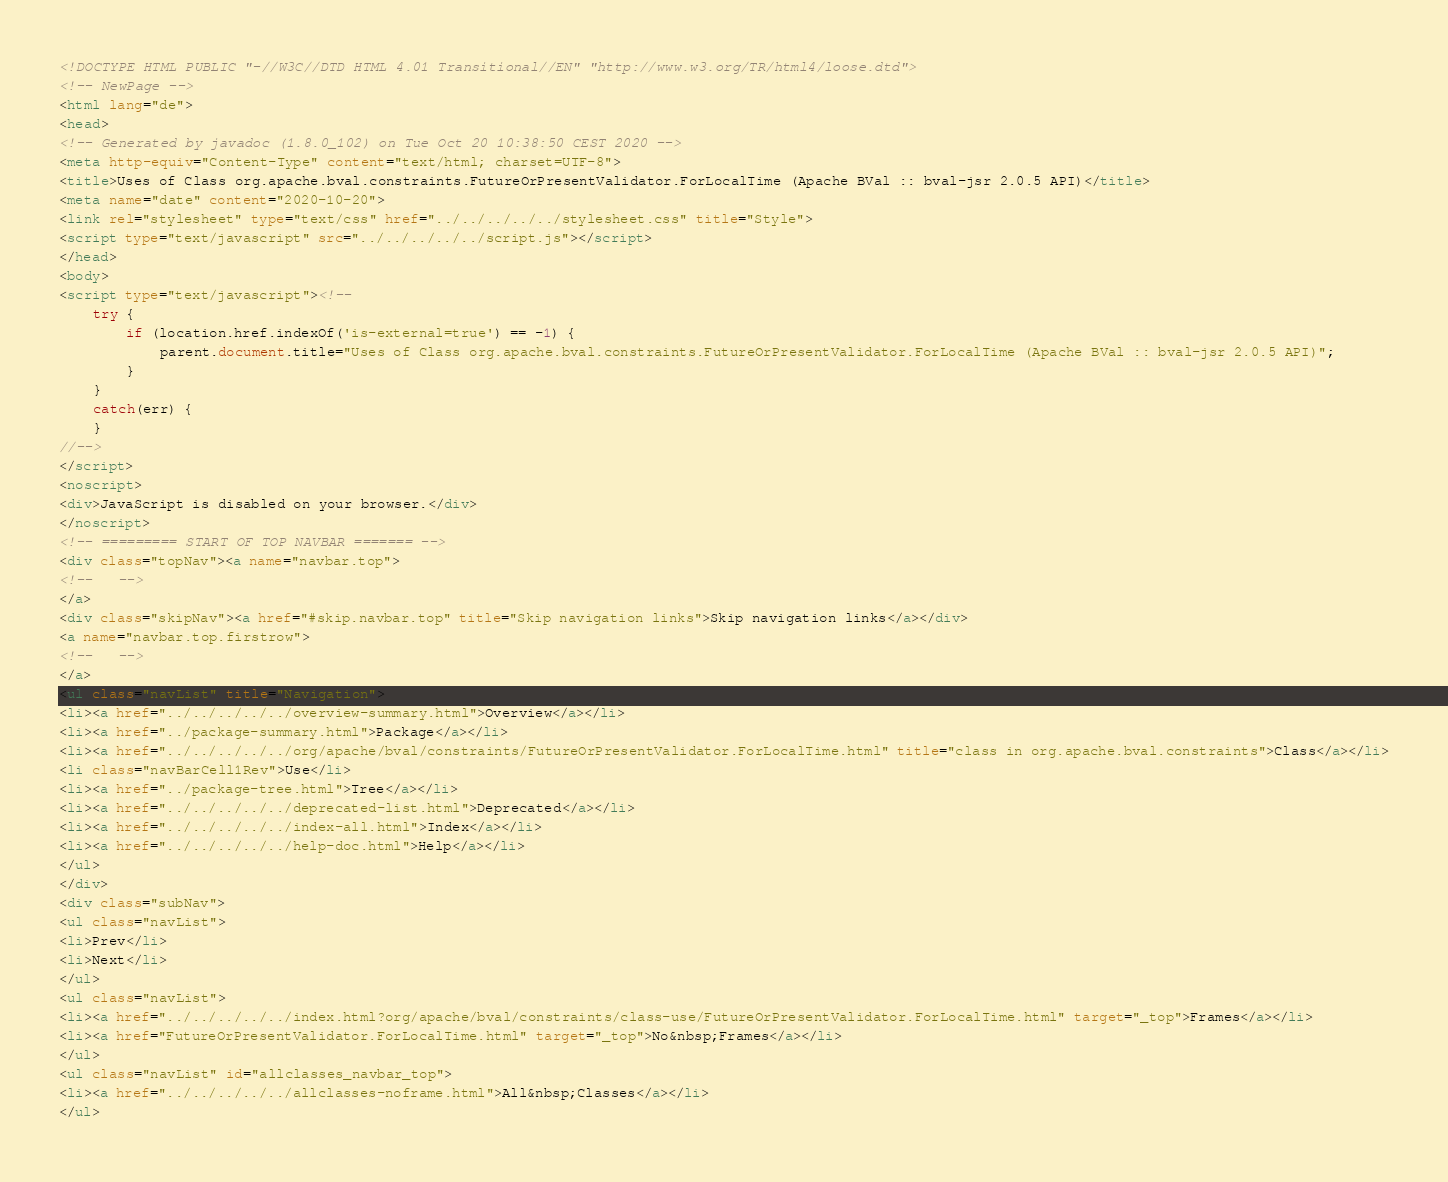<code> <loc_0><loc_0><loc_500><loc_500><_HTML_><!DOCTYPE HTML PUBLIC "-//W3C//DTD HTML 4.01 Transitional//EN" "http://www.w3.org/TR/html4/loose.dtd">
<!-- NewPage -->
<html lang="de">
<head>
<!-- Generated by javadoc (1.8.0_102) on Tue Oct 20 10:38:50 CEST 2020 -->
<meta http-equiv="Content-Type" content="text/html; charset=UTF-8">
<title>Uses of Class org.apache.bval.constraints.FutureOrPresentValidator.ForLocalTime (Apache BVal :: bval-jsr 2.0.5 API)</title>
<meta name="date" content="2020-10-20">
<link rel="stylesheet" type="text/css" href="../../../../../stylesheet.css" title="Style">
<script type="text/javascript" src="../../../../../script.js"></script>
</head>
<body>
<script type="text/javascript"><!--
    try {
        if (location.href.indexOf('is-external=true') == -1) {
            parent.document.title="Uses of Class org.apache.bval.constraints.FutureOrPresentValidator.ForLocalTime (Apache BVal :: bval-jsr 2.0.5 API)";
        }
    }
    catch(err) {
    }
//-->
</script>
<noscript>
<div>JavaScript is disabled on your browser.</div>
</noscript>
<!-- ========= START OF TOP NAVBAR ======= -->
<div class="topNav"><a name="navbar.top">
<!--   -->
</a>
<div class="skipNav"><a href="#skip.navbar.top" title="Skip navigation links">Skip navigation links</a></div>
<a name="navbar.top.firstrow">
<!--   -->
</a>
<ul class="navList" title="Navigation">
<li><a href="../../../../../overview-summary.html">Overview</a></li>
<li><a href="../package-summary.html">Package</a></li>
<li><a href="../../../../../org/apache/bval/constraints/FutureOrPresentValidator.ForLocalTime.html" title="class in org.apache.bval.constraints">Class</a></li>
<li class="navBarCell1Rev">Use</li>
<li><a href="../package-tree.html">Tree</a></li>
<li><a href="../../../../../deprecated-list.html">Deprecated</a></li>
<li><a href="../../../../../index-all.html">Index</a></li>
<li><a href="../../../../../help-doc.html">Help</a></li>
</ul>
</div>
<div class="subNav">
<ul class="navList">
<li>Prev</li>
<li>Next</li>
</ul>
<ul class="navList">
<li><a href="../../../../../index.html?org/apache/bval/constraints/class-use/FutureOrPresentValidator.ForLocalTime.html" target="_top">Frames</a></li>
<li><a href="FutureOrPresentValidator.ForLocalTime.html" target="_top">No&nbsp;Frames</a></li>
</ul>
<ul class="navList" id="allclasses_navbar_top">
<li><a href="../../../../../allclasses-noframe.html">All&nbsp;Classes</a></li>
</ul></code> 